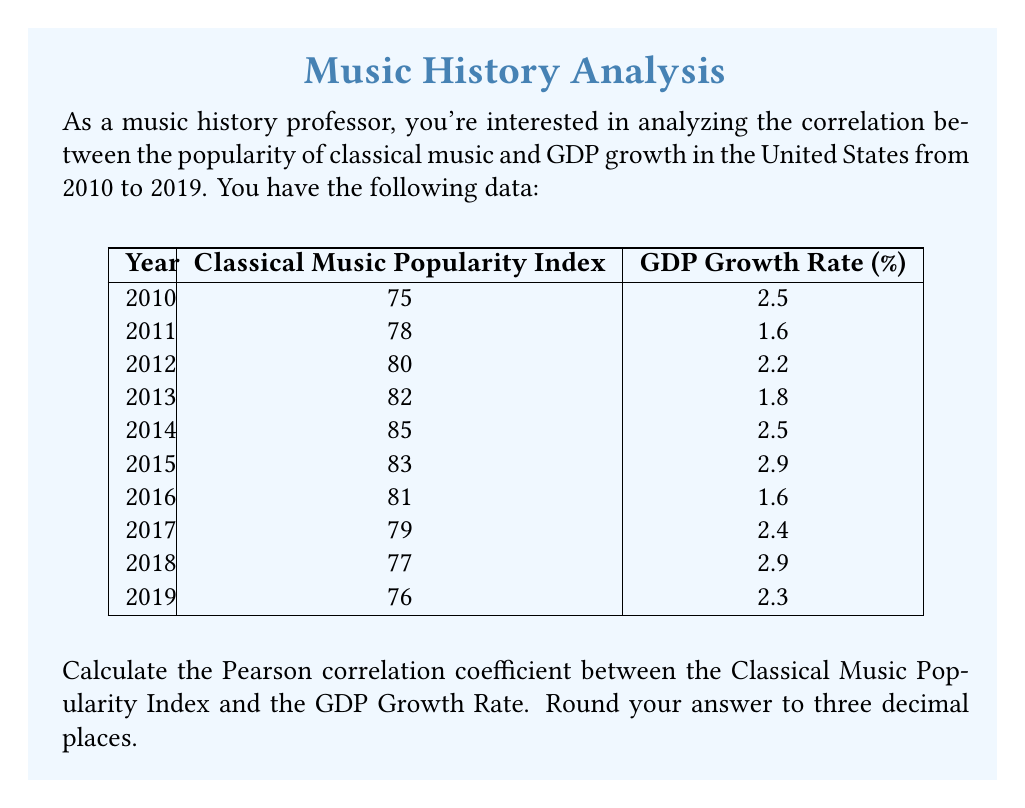Give your solution to this math problem. To calculate the Pearson correlation coefficient, we'll use the formula:

$$ r = \frac{\sum_{i=1}^{n} (x_i - \bar{x})(y_i - \bar{y})}{\sqrt{\sum_{i=1}^{n} (x_i - \bar{x})^2} \sqrt{\sum_{i=1}^{n} (y_i - \bar{y})^2}} $$

Where:
$x_i$ = Classical Music Popularity Index
$y_i$ = GDP Growth Rate
$\bar{x}$ = Mean of Classical Music Popularity Index
$\bar{y}$ = Mean of GDP Growth Rate
$n$ = Number of years (10)

Step 1: Calculate the means
$\bar{x} = \frac{75 + 78 + 80 + 82 + 85 + 83 + 81 + 79 + 77 + 76}{10} = 79.6$
$\bar{y} = \frac{2.5 + 1.6 + 2.2 + 1.8 + 2.5 + 2.9 + 1.6 + 2.4 + 2.9 + 2.3}{10} = 2.27$

Step 2: Calculate $(x_i - \bar{x})$, $(y_i - \bar{y})$, $(x_i - \bar{x})^2$, $(y_i - \bar{y})^2$, and $(x_i - \bar{x})(y_i - \bar{y})$ for each year

Step 3: Sum up the calculated values
$\sum (x_i - \bar{x})(y_i - \bar{y}) = -1.518$
$\sum (x_i - \bar{x})^2 = 98.4$
$\sum (y_i - \bar{y})^2 = 1.8486$

Step 4: Apply the formula
$$ r = \frac{-1.518}{\sqrt{98.4} \sqrt{1.8486}} = -0.11272 $$

Step 5: Round to three decimal places
$r = -0.113$
Answer: -0.113 